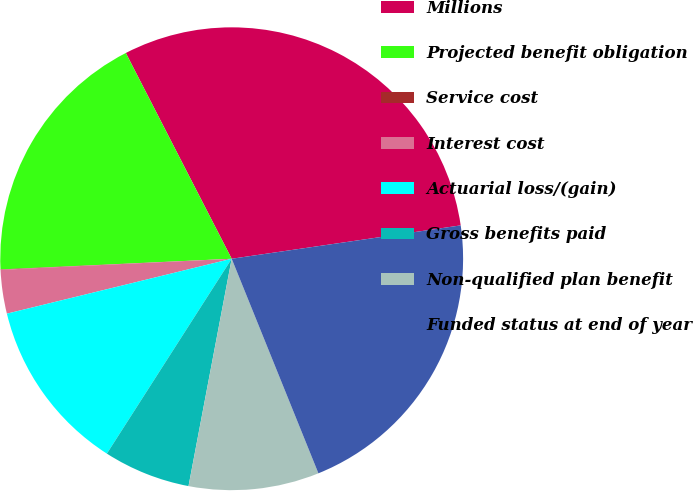Convert chart. <chart><loc_0><loc_0><loc_500><loc_500><pie_chart><fcel>Millions<fcel>Projected benefit obligation<fcel>Service cost<fcel>Interest cost<fcel>Actuarial loss/(gain)<fcel>Gross benefits paid<fcel>Non-qualified plan benefit<fcel>Funded status at end of year<nl><fcel>30.26%<fcel>18.17%<fcel>0.03%<fcel>3.05%<fcel>12.12%<fcel>6.08%<fcel>9.1%<fcel>21.19%<nl></chart> 